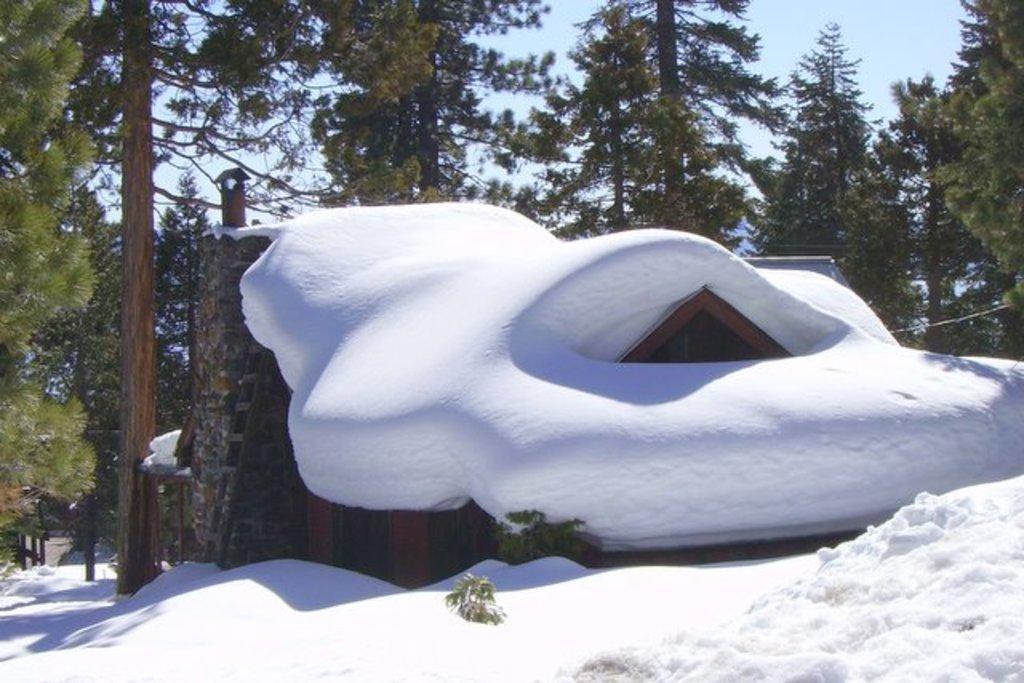Could you give a brief overview of what you see in this image? In the image there is a building in the middle with snow covered all over it, in the back there are trees and above its sky. 